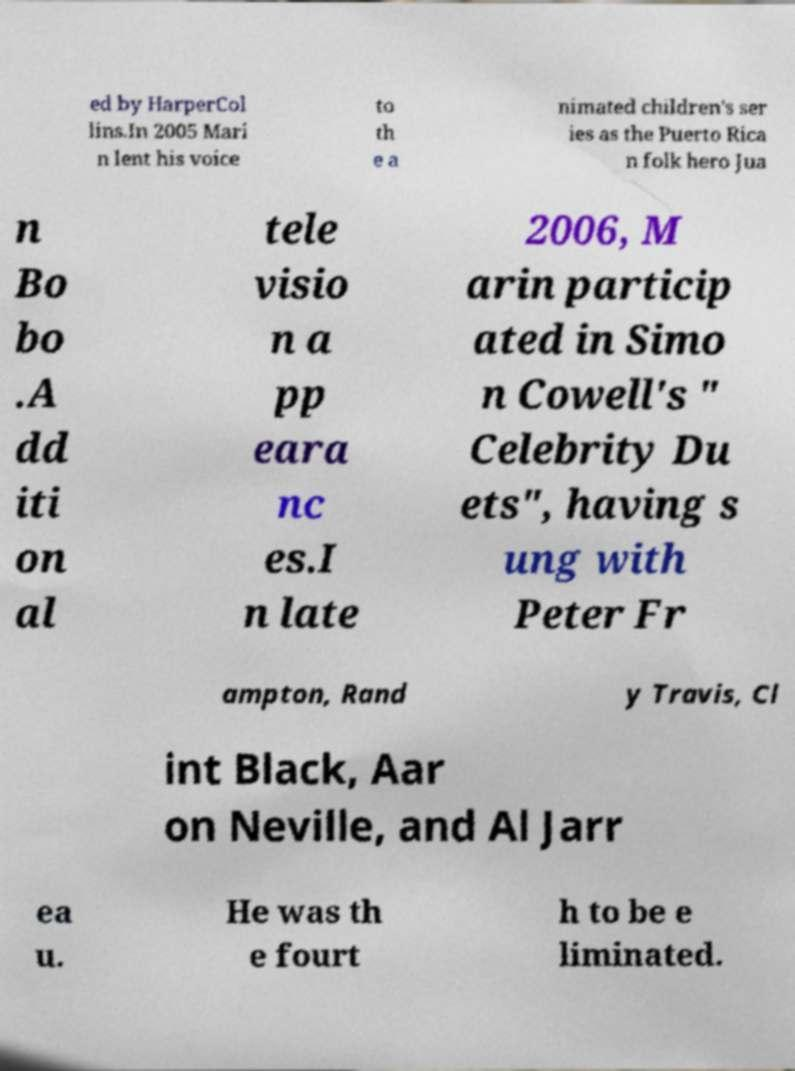Can you accurately transcribe the text from the provided image for me? ed by HarperCol lins.In 2005 Mari n lent his voice to th e a nimated children's ser ies as the Puerto Rica n folk hero Jua n Bo bo .A dd iti on al tele visio n a pp eara nc es.I n late 2006, M arin particip ated in Simo n Cowell's " Celebrity Du ets", having s ung with Peter Fr ampton, Rand y Travis, Cl int Black, Aar on Neville, and Al Jarr ea u. He was th e fourt h to be e liminated. 